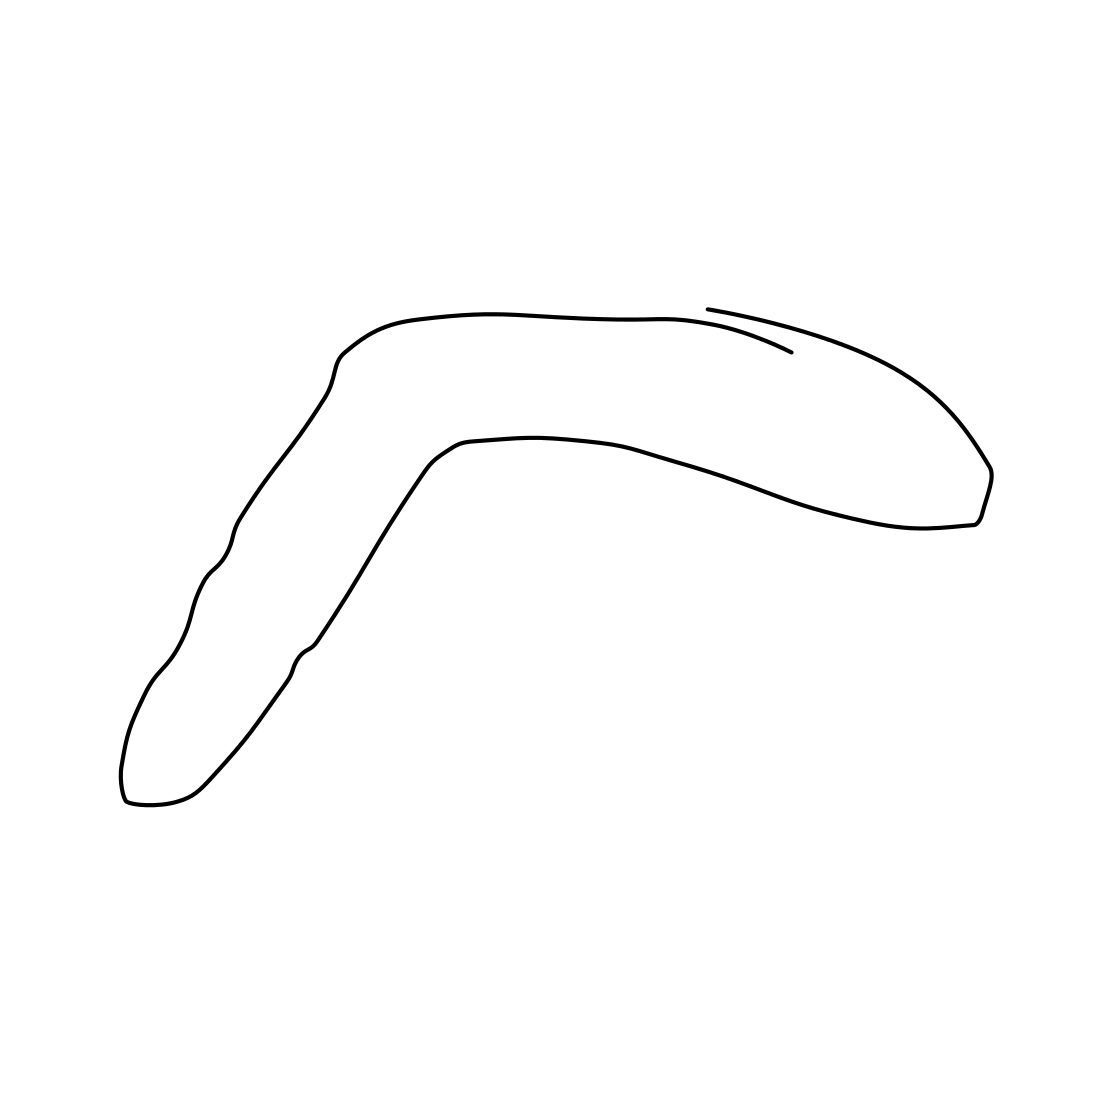Could this image represent any specific concept or idea? Yes, the image's simplicity and the boomerang shape could symbolize concepts such as return, cyclic movements, or continuity. It might also evoke themes of minimalism and essential form in art or design. Is there a cultural or historical significance to shapes like this one? Indeed, boomerang shapes are deeply rooted in Indigenous Australian culture, used historically as hunting tools and also bearing symbolic meanings related to survival and return. In a broader sense, similar shapes can be found in various cultures symbolizing cycles and renewal. 